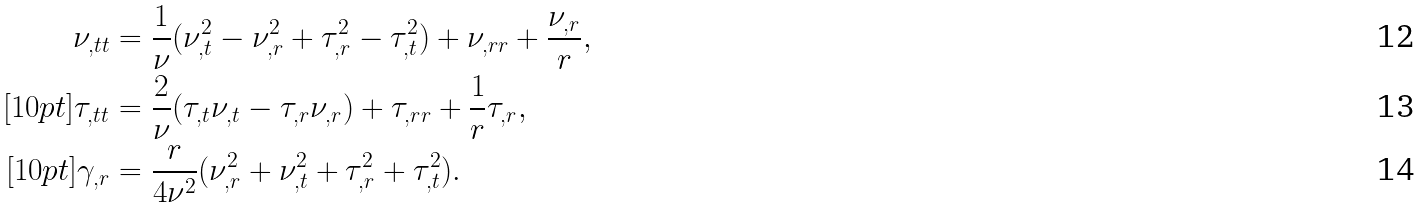Convert formula to latex. <formula><loc_0><loc_0><loc_500><loc_500>\nu _ { , t t } & = \frac { 1 } { \nu } ( \nu _ { , t } ^ { 2 } - \nu _ { , r } ^ { 2 } + \tau _ { , r } ^ { 2 } - \tau _ { , t } ^ { 2 } ) + \nu _ { , r r } + \frac { \nu _ { , r } } { r } , \\ [ 1 0 p t ] \tau _ { , t t } & = \frac { 2 } { \nu } ( \tau _ { , t } \nu _ { , t } - \tau _ { , r } \nu _ { , r } ) + \tau _ { , r r } + \frac { 1 } { r } \tau _ { , r } , \\ [ 1 0 p t ] \gamma _ { , r } & = \frac { r } { 4 \nu ^ { 2 } } ( \nu _ { , r } ^ { 2 } + \nu _ { , t } ^ { 2 } + \tau _ { , r } ^ { 2 } + \tau _ { , t } ^ { 2 } ) .</formula> 